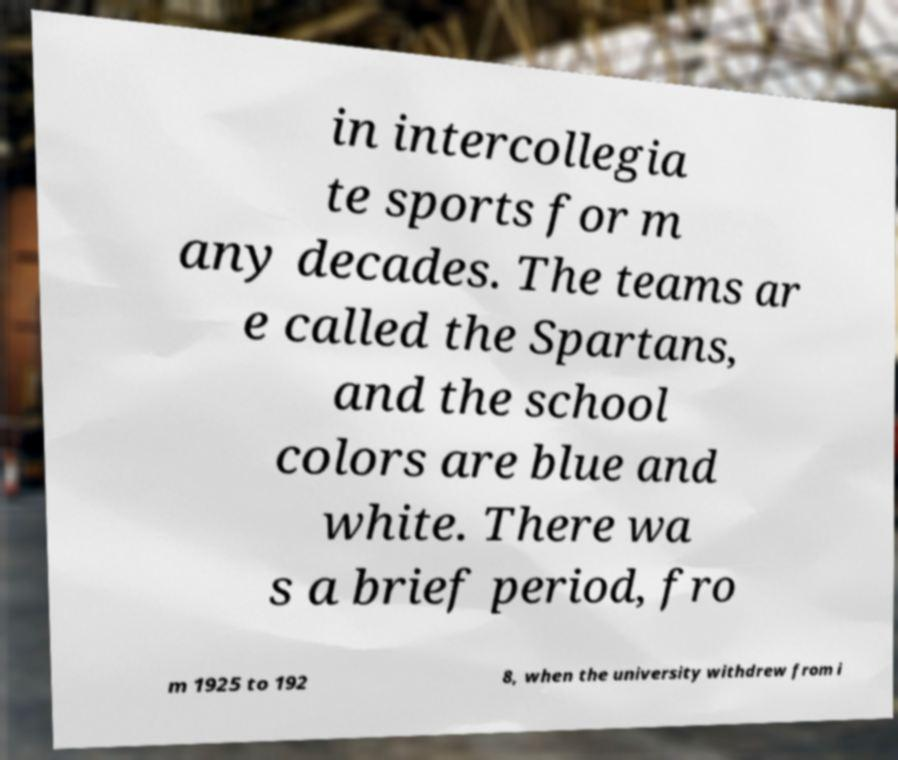There's text embedded in this image that I need extracted. Can you transcribe it verbatim? in intercollegia te sports for m any decades. The teams ar e called the Spartans, and the school colors are blue and white. There wa s a brief period, fro m 1925 to 192 8, when the university withdrew from i 